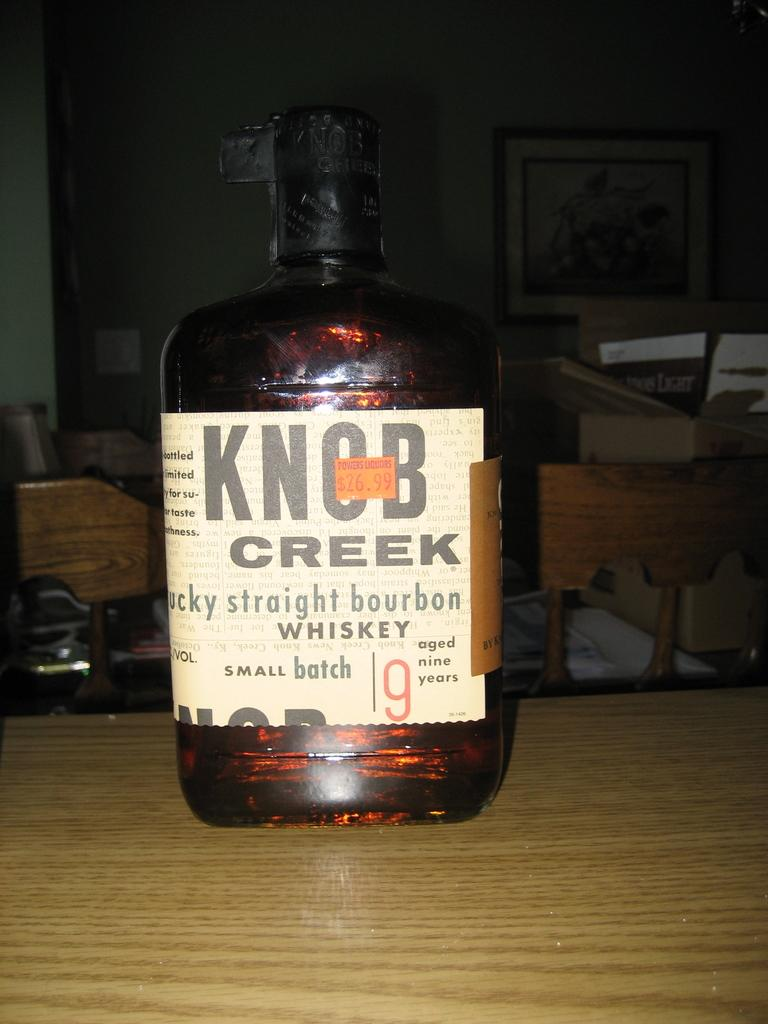Provide a one-sentence caption for the provided image. a bottle of kentucky straight bourbon whiskey called knob creek. 